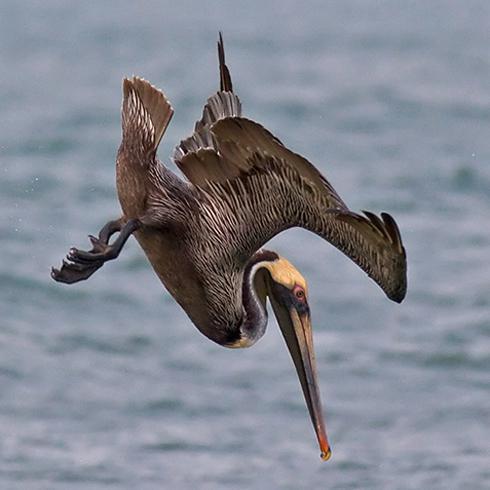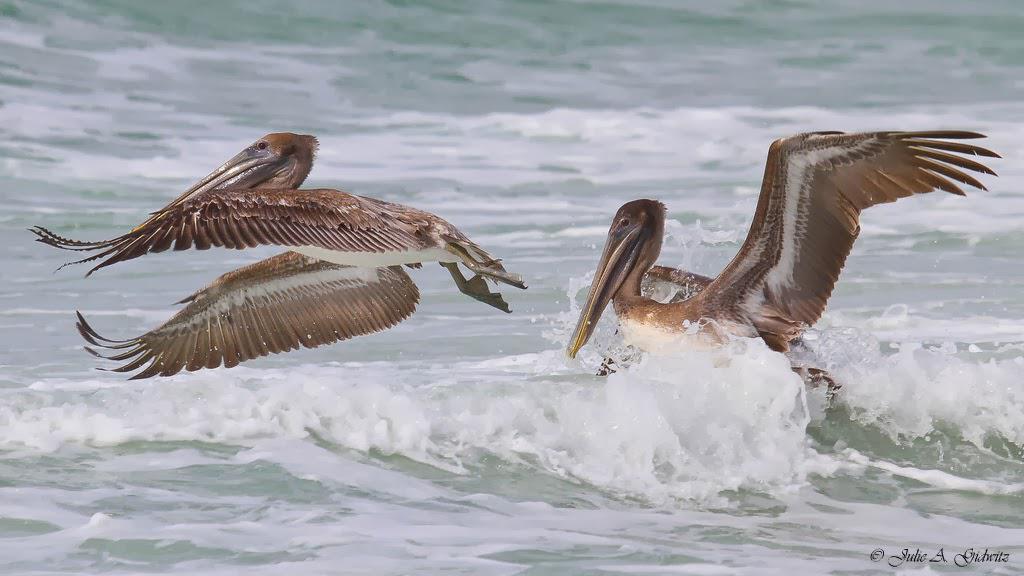The first image is the image on the left, the second image is the image on the right. For the images shown, is this caption "The bird in the image on the left is flying." true? Answer yes or no. Yes. The first image is the image on the left, the second image is the image on the right. For the images shown, is this caption "There are more pelican birds in the right image than in the left." true? Answer yes or no. Yes. 